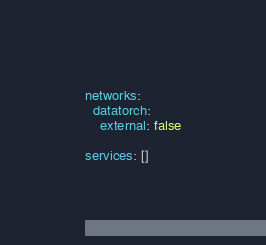Convert code to text. <code><loc_0><loc_0><loc_500><loc_500><_YAML_>networks:
  datatorch:
    external: false

services: []
</code> 